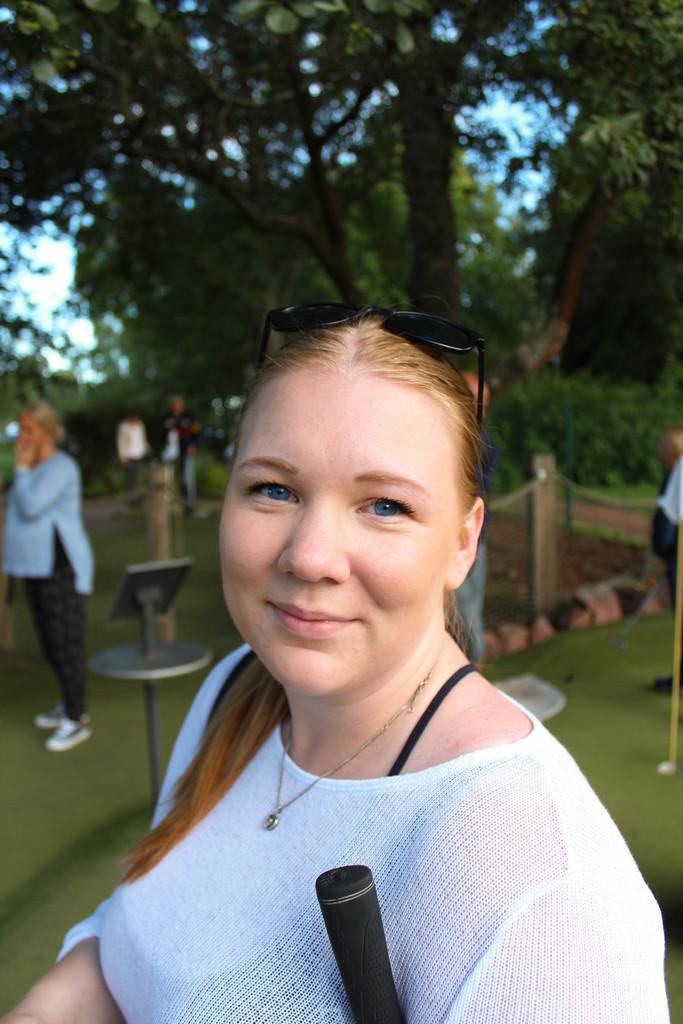Could you give a brief overview of what you see in this image? In this image there is a woman with a smile on her face, behind the woman there is another woman, in the background of the image there are trees. 